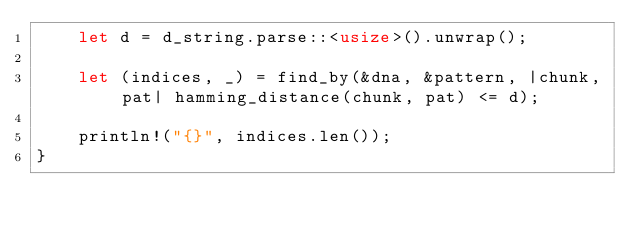<code> <loc_0><loc_0><loc_500><loc_500><_Rust_>    let d = d_string.parse::<usize>().unwrap();

    let (indices, _) = find_by(&dna, &pattern, |chunk, pat| hamming_distance(chunk, pat) <= d);

    println!("{}", indices.len());
}
</code> 